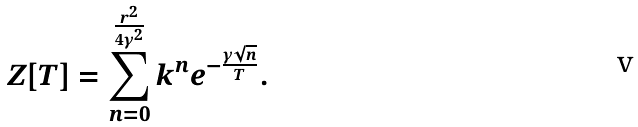Convert formula to latex. <formula><loc_0><loc_0><loc_500><loc_500>Z [ T ] = \sum _ { n = 0 } ^ { \frac { r ^ { 2 } } { 4 \gamma ^ { 2 } } } k ^ { n } e ^ { - \frac { \gamma \sqrt { n } } { T } } .</formula> 